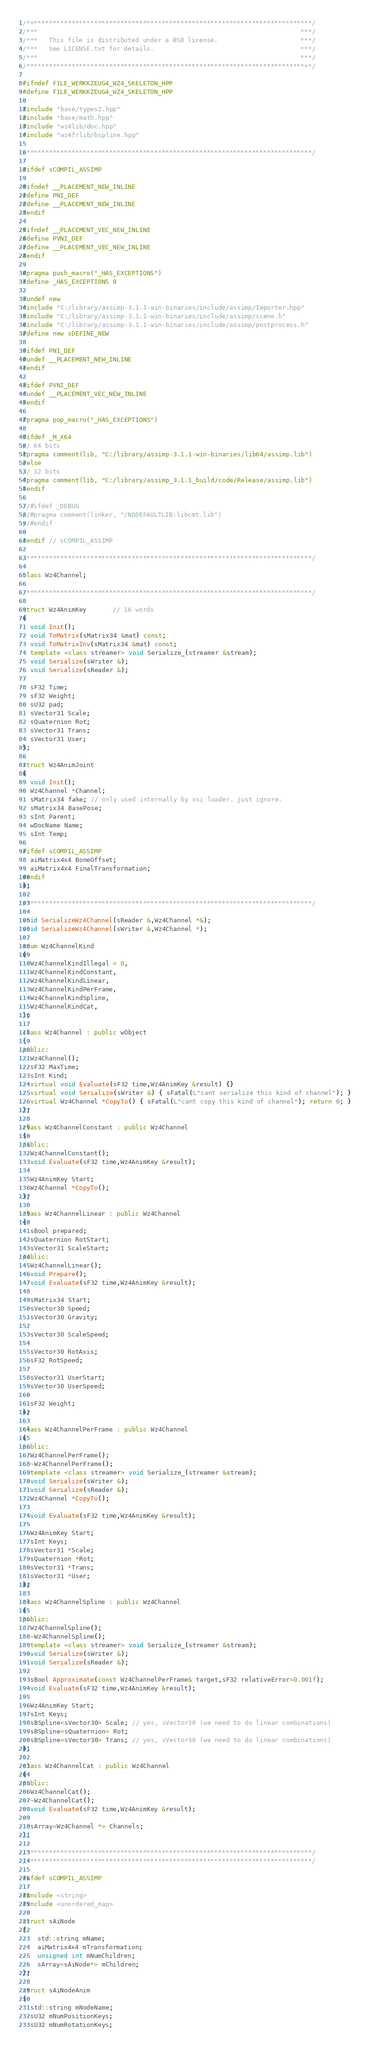Convert code to text. <code><loc_0><loc_0><loc_500><loc_500><_C++_>/*+**************************************************************************/
/***                                                                      ***/
/***   This file is distributed under a BSD license.                      ***/
/***   See LICENSE.txt for details.                                       ***/
/***                                                                      ***/
/**************************************************************************+*/

#ifndef FILE_WERKKZEUG4_WZ4_SKELETON_HPP
#define FILE_WERKKZEUG4_WZ4_SKELETON_HPP

#include "base/types2.hpp"
#include "base/math.hpp"
#include "wz4lib/doc.hpp"
#include "wz4frlib/bspline.hpp"

/****************************************************************************/

#ifdef sCOMPIL_ASSIMP

#ifndef __PLACEMENT_NEW_INLINE
#define PNI_DEF
#define __PLACEMENT_NEW_INLINE
#endif

#ifndef __PLACEMENT_VEC_NEW_INLINE
#define PVNI_DEF
#define __PLACEMENT_VEC_NEW_INLINE
#endif

#pragma push_macro("_HAS_EXCEPTIONS")
#define _HAS_EXCEPTIONS 0

#undef new
#include "C:/library/assimp-3.1.1-win-binaries/include/assimp/Importer.hpp"
#include "C:/library/assimp-3.1.1-win-binaries/include/assimp/scene.h"
#include "C:/library/assimp-3.1.1-win-binaries/include/assimp/postprocess.h"
#define new sDEFINE_NEW

#ifdef PNI_DEF
#undef __PLACEMENT_NEW_INLINE
#endif

#ifdef PVNI_DEF
#undef __PLACEMENT_VEC_NEW_INLINE
#endif

#pragma pop_macro("_HAS_EXCEPTIONS")

#ifdef _M_X64
// 64 bits
#pragma comment(lib, "C:/library/assimp-3.1.1-win-binaries/lib64/assimp.lib")
#else
// 32 bits
#pragma comment(lib, "C:/library/assimp_3.1.1_build/code/Release/assimp.lib")
#endif

//#ifdef _DEBUG
//#pragma comment(linker, "/NODEFAULTLIB:libcmt.lib")
//#endif

#endif // sCOMPIL_ASSIMP

/****************************************************************************/

class Wz4Channel;

/****************************************************************************/

struct Wz4AnimKey       // 16 words
{
  void Init();
  void ToMatrix(sMatrix34 &mat) const;
  void ToMatrixInv(sMatrix34 &mat) const;
  template <class streamer> void Serialize_(streamer &stream);
  void Serialize(sWriter &);
  void Serialize(sReader &);

  sF32 Time;
  sF32 Weight;
  sU32 pad;
  sVector31 Scale;
  sQuaternion Rot;
  sVector31 Trans;
  sVector31 User;
};

struct Wz4AnimJoint 
{
  void Init();
  Wz4Channel *Channel;
  sMatrix34 fake; // only used internally by xsi loader. just ignore.
  sMatrix34 BasePose;
  sInt Parent;
  wDocName Name;
  sInt Temp;

#ifdef sCOMPIL_ASSIMP
  aiMatrix4x4 BoneOffset;
  aiMatrix4x4 FinalTransformation;
#endif
};

/****************************************************************************/

void SerializeWz4Channel(sReader &,Wz4Channel *&);
void SerializeWz4Channel(sWriter &,Wz4Channel *);

enum Wz4ChannelKind
{
  Wz4ChannelKindIllegal = 0,
  Wz4ChannelKindConstant,
  Wz4ChannelKindLinear,
  Wz4ChannelKindPerFrame,
  Wz4ChannelKindSpline,
  Wz4ChannelKindCat,
};

class Wz4Channel : public wObject
{
public:
  Wz4Channel();
  sF32 MaxTime;
  sInt Kind;
  virtual void Evaluate(sF32 time,Wz4AnimKey &result) {}
  virtual void Serialize(sWriter &) { sFatal(L"cant serialize this kind of channel"); }
  virtual Wz4Channel *CopyTo() { sFatal(L"cant copy this kind of channel"); return 0; }
};

class Wz4ChannelConstant : public Wz4Channel
{
public:
  Wz4ChannelConstant();
  void Evaluate(sF32 time,Wz4AnimKey &result);

  Wz4AnimKey Start;
  Wz4Channel *CopyTo();
};

class Wz4ChannelLinear : public Wz4Channel
{
  sBool prepared;
  sQuaternion RotStart;
  sVector31 ScaleStart;
public:
  Wz4ChannelLinear();
  void Prepare();
  void Evaluate(sF32 time,Wz4AnimKey &result);

  sMatrix34 Start;
  sVector30 Speed;
  sVector30 Gravity;

  sVector30 ScaleSpeed;

  sVector30 RotAxis;
  sF32 RotSpeed;

  sVector31 UserStart;
  sVector30 UserSpeed;

  sF32 Weight;
};

class Wz4ChannelPerFrame : public Wz4Channel
{
public:
  Wz4ChannelPerFrame();
  ~Wz4ChannelPerFrame();
  template <class streamer> void Serialize_(streamer &stream);
  void Serialize(sWriter &);
  void Serialize(sReader &);
  Wz4Channel *CopyTo();

  void Evaluate(sF32 time,Wz4AnimKey &result);

  Wz4AnimKey Start;
  sInt Keys;
  sVector31 *Scale;
  sQuaternion *Rot;
  sVector31 *Trans;
  sVector31 *User;
};

class Wz4ChannelSpline : public Wz4Channel
{
public:
  Wz4ChannelSpline();
  ~Wz4ChannelSpline();
  template <class streamer> void Serialize_(streamer &stream);
  void Serialize(sWriter &);
  void Serialize(sReader &);

  sBool Approximate(const Wz4ChannelPerFrame& target,sF32 relativeError=0.001f);
  void Evaluate(sF32 time,Wz4AnimKey &result);

  Wz4AnimKey Start;
  sInt Keys;
  sBSpline<sVector30> Scale; // yes, sVector30 (we need to do linear combinations)
  sBSpline<sQuaternion> Rot;
  sBSpline<sVector30> Trans; // yes, sVector30 (we need to do linear combinations)
};

class Wz4ChannelCat : public Wz4Channel
{
public:
  Wz4ChannelCat();
  ~Wz4ChannelCat();
  void Evaluate(sF32 time,Wz4AnimKey &result);

  sArray<Wz4Channel *> Channels;
};

/****************************************************************************/
/****************************************************************************/

#ifdef sCOMPIL_ASSIMP

#include <string>
#include <unordered_map>

struct sAiNode
{
	std::string mName;
	aiMatrix4x4 mTransformation;
	unsigned int mNumChildren;
	sArray<sAiNode*> mChildren;
};

struct sAiNodeAnim
{
  std::string mNodeName;
  sU32 mNumPositionKeys;
  sU32 mNumRotationKeys;</code> 